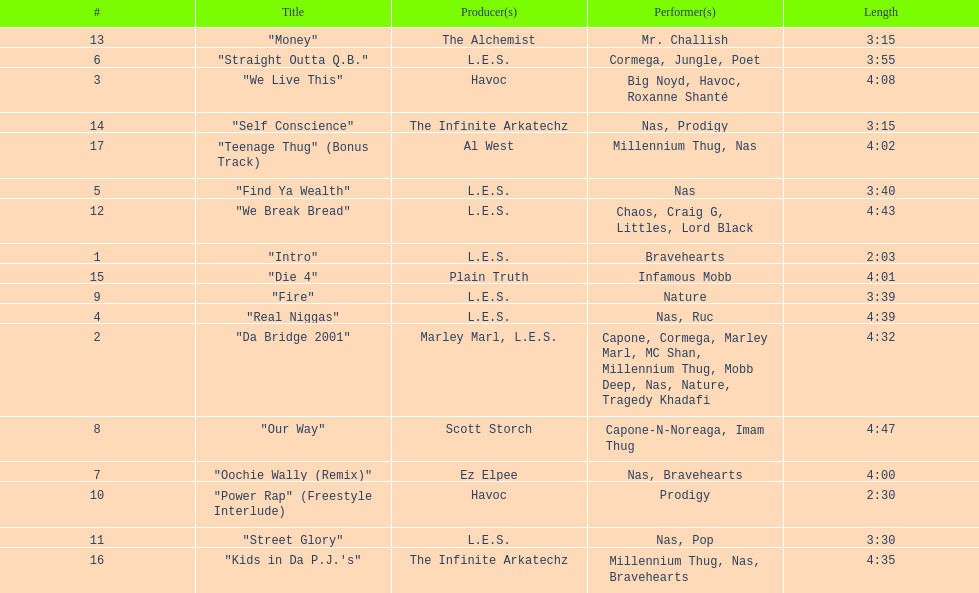How long is the shortest song on the album? 2:03. 